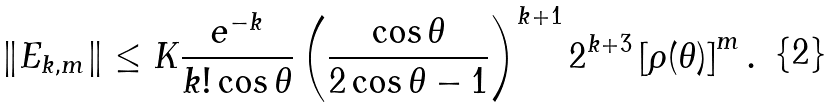Convert formula to latex. <formula><loc_0><loc_0><loc_500><loc_500>\left \| E _ { k , m } \right \| \leq K \frac { e ^ { - k } } { k ! \cos \theta } \left ( \frac { \cos \theta } { 2 \cos \theta - 1 } \right ) ^ { k + 1 } 2 ^ { k + 3 } \left [ \rho ( \theta ) \right ] ^ { m } .</formula> 